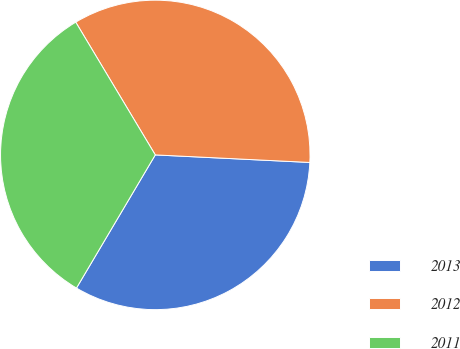Convert chart. <chart><loc_0><loc_0><loc_500><loc_500><pie_chart><fcel>2013<fcel>2012<fcel>2011<nl><fcel>32.73%<fcel>34.37%<fcel>32.9%<nl></chart> 